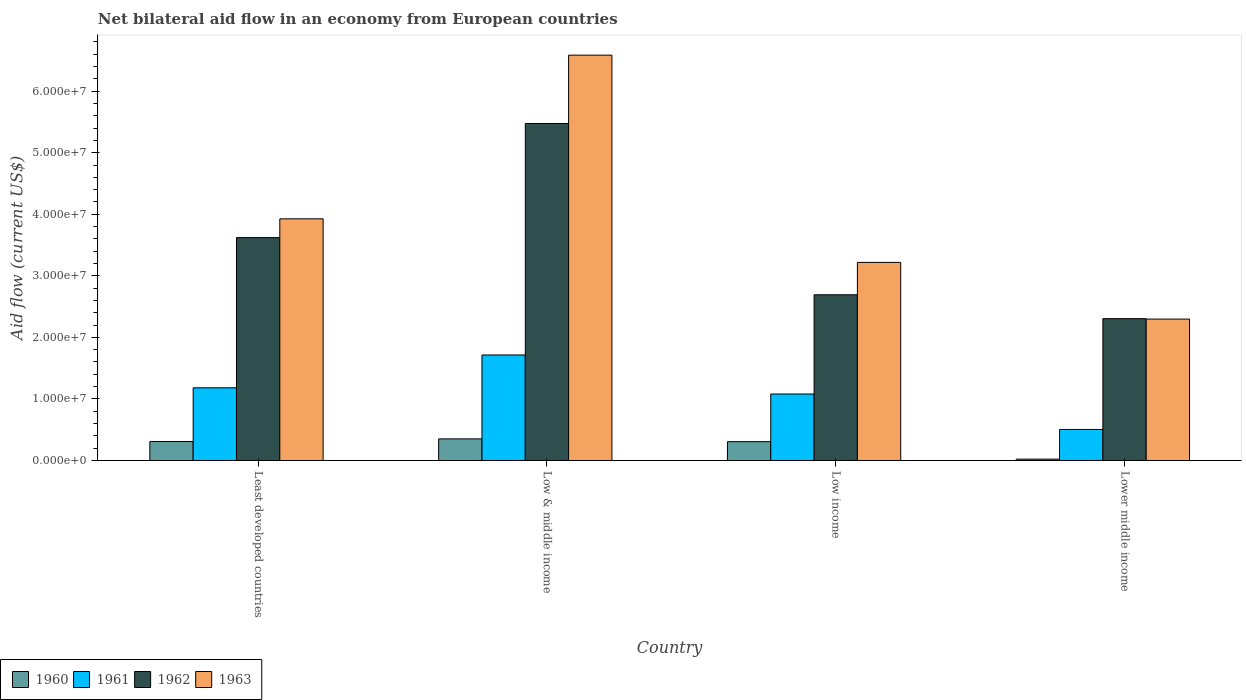How many different coloured bars are there?
Your answer should be compact. 4. Are the number of bars per tick equal to the number of legend labels?
Provide a short and direct response. Yes. Are the number of bars on each tick of the X-axis equal?
Keep it short and to the point. Yes. How many bars are there on the 2nd tick from the right?
Your answer should be compact. 4. What is the label of the 1st group of bars from the left?
Provide a succinct answer. Least developed countries. What is the net bilateral aid flow in 1960 in Least developed countries?
Provide a short and direct response. 3.08e+06. Across all countries, what is the maximum net bilateral aid flow in 1962?
Offer a terse response. 5.48e+07. Across all countries, what is the minimum net bilateral aid flow in 1963?
Offer a very short reply. 2.30e+07. In which country was the net bilateral aid flow in 1961 minimum?
Offer a terse response. Lower middle income. What is the total net bilateral aid flow in 1961 in the graph?
Give a very brief answer. 4.48e+07. What is the difference between the net bilateral aid flow in 1960 in Least developed countries and that in Lower middle income?
Provide a short and direct response. 2.86e+06. What is the difference between the net bilateral aid flow in 1960 in Lower middle income and the net bilateral aid flow in 1961 in Low & middle income?
Ensure brevity in your answer.  -1.69e+07. What is the average net bilateral aid flow in 1963 per country?
Give a very brief answer. 4.01e+07. What is the difference between the net bilateral aid flow of/in 1963 and net bilateral aid flow of/in 1962 in Low income?
Give a very brief answer. 5.26e+06. In how many countries, is the net bilateral aid flow in 1963 greater than 24000000 US$?
Provide a succinct answer. 3. What is the ratio of the net bilateral aid flow in 1962 in Low & middle income to that in Low income?
Your answer should be compact. 2.03. Is the net bilateral aid flow in 1963 in Least developed countries less than that in Low & middle income?
Give a very brief answer. Yes. What is the difference between the highest and the lowest net bilateral aid flow in 1963?
Provide a short and direct response. 4.29e+07. In how many countries, is the net bilateral aid flow in 1960 greater than the average net bilateral aid flow in 1960 taken over all countries?
Your answer should be compact. 3. Is the sum of the net bilateral aid flow in 1963 in Least developed countries and Low income greater than the maximum net bilateral aid flow in 1960 across all countries?
Offer a very short reply. Yes. What does the 2nd bar from the right in Least developed countries represents?
Offer a very short reply. 1962. Are all the bars in the graph horizontal?
Offer a terse response. No. How many countries are there in the graph?
Offer a very short reply. 4. Does the graph contain any zero values?
Your answer should be compact. No. Does the graph contain grids?
Keep it short and to the point. No. What is the title of the graph?
Offer a very short reply. Net bilateral aid flow in an economy from European countries. Does "1992" appear as one of the legend labels in the graph?
Offer a very short reply. No. What is the label or title of the Y-axis?
Provide a short and direct response. Aid flow (current US$). What is the Aid flow (current US$) of 1960 in Least developed countries?
Make the answer very short. 3.08e+06. What is the Aid flow (current US$) in 1961 in Least developed countries?
Provide a short and direct response. 1.18e+07. What is the Aid flow (current US$) of 1962 in Least developed countries?
Your answer should be compact. 3.62e+07. What is the Aid flow (current US$) of 1963 in Least developed countries?
Keep it short and to the point. 3.93e+07. What is the Aid flow (current US$) of 1960 in Low & middle income?
Offer a very short reply. 3.51e+06. What is the Aid flow (current US$) in 1961 in Low & middle income?
Your answer should be very brief. 1.71e+07. What is the Aid flow (current US$) of 1962 in Low & middle income?
Your response must be concise. 5.48e+07. What is the Aid flow (current US$) of 1963 in Low & middle income?
Your answer should be very brief. 6.58e+07. What is the Aid flow (current US$) of 1960 in Low income?
Provide a succinct answer. 3.06e+06. What is the Aid flow (current US$) of 1961 in Low income?
Ensure brevity in your answer.  1.08e+07. What is the Aid flow (current US$) in 1962 in Low income?
Your response must be concise. 2.69e+07. What is the Aid flow (current US$) in 1963 in Low income?
Ensure brevity in your answer.  3.22e+07. What is the Aid flow (current US$) in 1961 in Lower middle income?
Your answer should be compact. 5.04e+06. What is the Aid flow (current US$) of 1962 in Lower middle income?
Keep it short and to the point. 2.30e+07. What is the Aid flow (current US$) of 1963 in Lower middle income?
Keep it short and to the point. 2.30e+07. Across all countries, what is the maximum Aid flow (current US$) of 1960?
Provide a short and direct response. 3.51e+06. Across all countries, what is the maximum Aid flow (current US$) in 1961?
Offer a terse response. 1.71e+07. Across all countries, what is the maximum Aid flow (current US$) of 1962?
Offer a very short reply. 5.48e+07. Across all countries, what is the maximum Aid flow (current US$) in 1963?
Your response must be concise. 6.58e+07. Across all countries, what is the minimum Aid flow (current US$) in 1961?
Ensure brevity in your answer.  5.04e+06. Across all countries, what is the minimum Aid flow (current US$) in 1962?
Offer a very short reply. 2.30e+07. Across all countries, what is the minimum Aid flow (current US$) of 1963?
Give a very brief answer. 2.30e+07. What is the total Aid flow (current US$) of 1960 in the graph?
Your response must be concise. 9.87e+06. What is the total Aid flow (current US$) in 1961 in the graph?
Your answer should be very brief. 4.48e+07. What is the total Aid flow (current US$) of 1962 in the graph?
Ensure brevity in your answer.  1.41e+08. What is the total Aid flow (current US$) in 1963 in the graph?
Offer a terse response. 1.60e+08. What is the difference between the Aid flow (current US$) in 1960 in Least developed countries and that in Low & middle income?
Your answer should be compact. -4.30e+05. What is the difference between the Aid flow (current US$) in 1961 in Least developed countries and that in Low & middle income?
Provide a succinct answer. -5.33e+06. What is the difference between the Aid flow (current US$) in 1962 in Least developed countries and that in Low & middle income?
Ensure brevity in your answer.  -1.85e+07. What is the difference between the Aid flow (current US$) of 1963 in Least developed countries and that in Low & middle income?
Keep it short and to the point. -2.66e+07. What is the difference between the Aid flow (current US$) in 1960 in Least developed countries and that in Low income?
Your answer should be compact. 2.00e+04. What is the difference between the Aid flow (current US$) in 1961 in Least developed countries and that in Low income?
Offer a very short reply. 1.01e+06. What is the difference between the Aid flow (current US$) in 1962 in Least developed countries and that in Low income?
Provide a succinct answer. 9.29e+06. What is the difference between the Aid flow (current US$) in 1963 in Least developed countries and that in Low income?
Keep it short and to the point. 7.08e+06. What is the difference between the Aid flow (current US$) in 1960 in Least developed countries and that in Lower middle income?
Your answer should be very brief. 2.86e+06. What is the difference between the Aid flow (current US$) of 1961 in Least developed countries and that in Lower middle income?
Provide a succinct answer. 6.77e+06. What is the difference between the Aid flow (current US$) in 1962 in Least developed countries and that in Lower middle income?
Make the answer very short. 1.32e+07. What is the difference between the Aid flow (current US$) of 1963 in Least developed countries and that in Lower middle income?
Give a very brief answer. 1.63e+07. What is the difference between the Aid flow (current US$) in 1961 in Low & middle income and that in Low income?
Offer a terse response. 6.34e+06. What is the difference between the Aid flow (current US$) of 1962 in Low & middle income and that in Low income?
Offer a terse response. 2.78e+07. What is the difference between the Aid flow (current US$) in 1963 in Low & middle income and that in Low income?
Your response must be concise. 3.37e+07. What is the difference between the Aid flow (current US$) of 1960 in Low & middle income and that in Lower middle income?
Give a very brief answer. 3.29e+06. What is the difference between the Aid flow (current US$) in 1961 in Low & middle income and that in Lower middle income?
Keep it short and to the point. 1.21e+07. What is the difference between the Aid flow (current US$) of 1962 in Low & middle income and that in Lower middle income?
Your answer should be very brief. 3.17e+07. What is the difference between the Aid flow (current US$) in 1963 in Low & middle income and that in Lower middle income?
Offer a very short reply. 4.29e+07. What is the difference between the Aid flow (current US$) in 1960 in Low income and that in Lower middle income?
Make the answer very short. 2.84e+06. What is the difference between the Aid flow (current US$) of 1961 in Low income and that in Lower middle income?
Offer a terse response. 5.76e+06. What is the difference between the Aid flow (current US$) in 1962 in Low income and that in Lower middle income?
Provide a short and direct response. 3.88e+06. What is the difference between the Aid flow (current US$) of 1963 in Low income and that in Lower middle income?
Keep it short and to the point. 9.21e+06. What is the difference between the Aid flow (current US$) of 1960 in Least developed countries and the Aid flow (current US$) of 1961 in Low & middle income?
Your answer should be very brief. -1.41e+07. What is the difference between the Aid flow (current US$) of 1960 in Least developed countries and the Aid flow (current US$) of 1962 in Low & middle income?
Give a very brief answer. -5.17e+07. What is the difference between the Aid flow (current US$) in 1960 in Least developed countries and the Aid flow (current US$) in 1963 in Low & middle income?
Give a very brief answer. -6.28e+07. What is the difference between the Aid flow (current US$) of 1961 in Least developed countries and the Aid flow (current US$) of 1962 in Low & middle income?
Your answer should be compact. -4.29e+07. What is the difference between the Aid flow (current US$) of 1961 in Least developed countries and the Aid flow (current US$) of 1963 in Low & middle income?
Your answer should be very brief. -5.40e+07. What is the difference between the Aid flow (current US$) of 1962 in Least developed countries and the Aid flow (current US$) of 1963 in Low & middle income?
Provide a succinct answer. -2.96e+07. What is the difference between the Aid flow (current US$) in 1960 in Least developed countries and the Aid flow (current US$) in 1961 in Low income?
Provide a succinct answer. -7.72e+06. What is the difference between the Aid flow (current US$) of 1960 in Least developed countries and the Aid flow (current US$) of 1962 in Low income?
Give a very brief answer. -2.38e+07. What is the difference between the Aid flow (current US$) in 1960 in Least developed countries and the Aid flow (current US$) in 1963 in Low income?
Offer a very short reply. -2.91e+07. What is the difference between the Aid flow (current US$) of 1961 in Least developed countries and the Aid flow (current US$) of 1962 in Low income?
Offer a terse response. -1.51e+07. What is the difference between the Aid flow (current US$) in 1961 in Least developed countries and the Aid flow (current US$) in 1963 in Low income?
Offer a terse response. -2.04e+07. What is the difference between the Aid flow (current US$) in 1962 in Least developed countries and the Aid flow (current US$) in 1963 in Low income?
Provide a short and direct response. 4.03e+06. What is the difference between the Aid flow (current US$) in 1960 in Least developed countries and the Aid flow (current US$) in 1961 in Lower middle income?
Offer a terse response. -1.96e+06. What is the difference between the Aid flow (current US$) in 1960 in Least developed countries and the Aid flow (current US$) in 1962 in Lower middle income?
Your answer should be compact. -2.00e+07. What is the difference between the Aid flow (current US$) in 1960 in Least developed countries and the Aid flow (current US$) in 1963 in Lower middle income?
Provide a short and direct response. -1.99e+07. What is the difference between the Aid flow (current US$) of 1961 in Least developed countries and the Aid flow (current US$) of 1962 in Lower middle income?
Give a very brief answer. -1.12e+07. What is the difference between the Aid flow (current US$) in 1961 in Least developed countries and the Aid flow (current US$) in 1963 in Lower middle income?
Your answer should be very brief. -1.12e+07. What is the difference between the Aid flow (current US$) in 1962 in Least developed countries and the Aid flow (current US$) in 1963 in Lower middle income?
Ensure brevity in your answer.  1.32e+07. What is the difference between the Aid flow (current US$) in 1960 in Low & middle income and the Aid flow (current US$) in 1961 in Low income?
Your answer should be very brief. -7.29e+06. What is the difference between the Aid flow (current US$) of 1960 in Low & middle income and the Aid flow (current US$) of 1962 in Low income?
Your answer should be compact. -2.34e+07. What is the difference between the Aid flow (current US$) of 1960 in Low & middle income and the Aid flow (current US$) of 1963 in Low income?
Make the answer very short. -2.87e+07. What is the difference between the Aid flow (current US$) in 1961 in Low & middle income and the Aid flow (current US$) in 1962 in Low income?
Your response must be concise. -9.78e+06. What is the difference between the Aid flow (current US$) of 1961 in Low & middle income and the Aid flow (current US$) of 1963 in Low income?
Make the answer very short. -1.50e+07. What is the difference between the Aid flow (current US$) in 1962 in Low & middle income and the Aid flow (current US$) in 1963 in Low income?
Provide a short and direct response. 2.26e+07. What is the difference between the Aid flow (current US$) of 1960 in Low & middle income and the Aid flow (current US$) of 1961 in Lower middle income?
Offer a very short reply. -1.53e+06. What is the difference between the Aid flow (current US$) of 1960 in Low & middle income and the Aid flow (current US$) of 1962 in Lower middle income?
Provide a short and direct response. -1.95e+07. What is the difference between the Aid flow (current US$) of 1960 in Low & middle income and the Aid flow (current US$) of 1963 in Lower middle income?
Provide a succinct answer. -1.95e+07. What is the difference between the Aid flow (current US$) in 1961 in Low & middle income and the Aid flow (current US$) in 1962 in Lower middle income?
Provide a short and direct response. -5.90e+06. What is the difference between the Aid flow (current US$) of 1961 in Low & middle income and the Aid flow (current US$) of 1963 in Lower middle income?
Provide a succinct answer. -5.83e+06. What is the difference between the Aid flow (current US$) in 1962 in Low & middle income and the Aid flow (current US$) in 1963 in Lower middle income?
Your answer should be compact. 3.18e+07. What is the difference between the Aid flow (current US$) in 1960 in Low income and the Aid flow (current US$) in 1961 in Lower middle income?
Provide a short and direct response. -1.98e+06. What is the difference between the Aid flow (current US$) of 1960 in Low income and the Aid flow (current US$) of 1962 in Lower middle income?
Make the answer very short. -2.00e+07. What is the difference between the Aid flow (current US$) of 1960 in Low income and the Aid flow (current US$) of 1963 in Lower middle income?
Your response must be concise. -1.99e+07. What is the difference between the Aid flow (current US$) of 1961 in Low income and the Aid flow (current US$) of 1962 in Lower middle income?
Provide a short and direct response. -1.22e+07. What is the difference between the Aid flow (current US$) in 1961 in Low income and the Aid flow (current US$) in 1963 in Lower middle income?
Your answer should be compact. -1.22e+07. What is the difference between the Aid flow (current US$) of 1962 in Low income and the Aid flow (current US$) of 1963 in Lower middle income?
Keep it short and to the point. 3.95e+06. What is the average Aid flow (current US$) in 1960 per country?
Make the answer very short. 2.47e+06. What is the average Aid flow (current US$) of 1961 per country?
Give a very brief answer. 1.12e+07. What is the average Aid flow (current US$) in 1962 per country?
Offer a terse response. 3.52e+07. What is the average Aid flow (current US$) of 1963 per country?
Ensure brevity in your answer.  4.01e+07. What is the difference between the Aid flow (current US$) in 1960 and Aid flow (current US$) in 1961 in Least developed countries?
Keep it short and to the point. -8.73e+06. What is the difference between the Aid flow (current US$) of 1960 and Aid flow (current US$) of 1962 in Least developed countries?
Offer a terse response. -3.31e+07. What is the difference between the Aid flow (current US$) of 1960 and Aid flow (current US$) of 1963 in Least developed countries?
Your response must be concise. -3.62e+07. What is the difference between the Aid flow (current US$) in 1961 and Aid flow (current US$) in 1962 in Least developed countries?
Your response must be concise. -2.44e+07. What is the difference between the Aid flow (current US$) in 1961 and Aid flow (current US$) in 1963 in Least developed countries?
Provide a succinct answer. -2.74e+07. What is the difference between the Aid flow (current US$) in 1962 and Aid flow (current US$) in 1963 in Least developed countries?
Provide a succinct answer. -3.05e+06. What is the difference between the Aid flow (current US$) in 1960 and Aid flow (current US$) in 1961 in Low & middle income?
Offer a terse response. -1.36e+07. What is the difference between the Aid flow (current US$) of 1960 and Aid flow (current US$) of 1962 in Low & middle income?
Keep it short and to the point. -5.12e+07. What is the difference between the Aid flow (current US$) of 1960 and Aid flow (current US$) of 1963 in Low & middle income?
Offer a terse response. -6.23e+07. What is the difference between the Aid flow (current US$) of 1961 and Aid flow (current US$) of 1962 in Low & middle income?
Give a very brief answer. -3.76e+07. What is the difference between the Aid flow (current US$) in 1961 and Aid flow (current US$) in 1963 in Low & middle income?
Provide a succinct answer. -4.87e+07. What is the difference between the Aid flow (current US$) in 1962 and Aid flow (current US$) in 1963 in Low & middle income?
Offer a terse response. -1.11e+07. What is the difference between the Aid flow (current US$) in 1960 and Aid flow (current US$) in 1961 in Low income?
Provide a succinct answer. -7.74e+06. What is the difference between the Aid flow (current US$) in 1960 and Aid flow (current US$) in 1962 in Low income?
Your answer should be compact. -2.39e+07. What is the difference between the Aid flow (current US$) of 1960 and Aid flow (current US$) of 1963 in Low income?
Keep it short and to the point. -2.91e+07. What is the difference between the Aid flow (current US$) of 1961 and Aid flow (current US$) of 1962 in Low income?
Give a very brief answer. -1.61e+07. What is the difference between the Aid flow (current US$) of 1961 and Aid flow (current US$) of 1963 in Low income?
Offer a terse response. -2.14e+07. What is the difference between the Aid flow (current US$) of 1962 and Aid flow (current US$) of 1963 in Low income?
Your response must be concise. -5.26e+06. What is the difference between the Aid flow (current US$) of 1960 and Aid flow (current US$) of 1961 in Lower middle income?
Your answer should be compact. -4.82e+06. What is the difference between the Aid flow (current US$) of 1960 and Aid flow (current US$) of 1962 in Lower middle income?
Give a very brief answer. -2.28e+07. What is the difference between the Aid flow (current US$) of 1960 and Aid flow (current US$) of 1963 in Lower middle income?
Offer a very short reply. -2.28e+07. What is the difference between the Aid flow (current US$) in 1961 and Aid flow (current US$) in 1962 in Lower middle income?
Offer a very short reply. -1.80e+07. What is the difference between the Aid flow (current US$) in 1961 and Aid flow (current US$) in 1963 in Lower middle income?
Keep it short and to the point. -1.79e+07. What is the difference between the Aid flow (current US$) in 1962 and Aid flow (current US$) in 1963 in Lower middle income?
Provide a succinct answer. 7.00e+04. What is the ratio of the Aid flow (current US$) of 1960 in Least developed countries to that in Low & middle income?
Provide a succinct answer. 0.88. What is the ratio of the Aid flow (current US$) of 1961 in Least developed countries to that in Low & middle income?
Your answer should be compact. 0.69. What is the ratio of the Aid flow (current US$) in 1962 in Least developed countries to that in Low & middle income?
Offer a very short reply. 0.66. What is the ratio of the Aid flow (current US$) in 1963 in Least developed countries to that in Low & middle income?
Your answer should be very brief. 0.6. What is the ratio of the Aid flow (current US$) in 1960 in Least developed countries to that in Low income?
Make the answer very short. 1.01. What is the ratio of the Aid flow (current US$) of 1961 in Least developed countries to that in Low income?
Keep it short and to the point. 1.09. What is the ratio of the Aid flow (current US$) in 1962 in Least developed countries to that in Low income?
Keep it short and to the point. 1.35. What is the ratio of the Aid flow (current US$) in 1963 in Least developed countries to that in Low income?
Provide a succinct answer. 1.22. What is the ratio of the Aid flow (current US$) in 1960 in Least developed countries to that in Lower middle income?
Your response must be concise. 14. What is the ratio of the Aid flow (current US$) in 1961 in Least developed countries to that in Lower middle income?
Provide a short and direct response. 2.34. What is the ratio of the Aid flow (current US$) in 1962 in Least developed countries to that in Lower middle income?
Keep it short and to the point. 1.57. What is the ratio of the Aid flow (current US$) of 1963 in Least developed countries to that in Lower middle income?
Provide a short and direct response. 1.71. What is the ratio of the Aid flow (current US$) of 1960 in Low & middle income to that in Low income?
Your answer should be very brief. 1.15. What is the ratio of the Aid flow (current US$) in 1961 in Low & middle income to that in Low income?
Provide a short and direct response. 1.59. What is the ratio of the Aid flow (current US$) in 1962 in Low & middle income to that in Low income?
Offer a terse response. 2.03. What is the ratio of the Aid flow (current US$) in 1963 in Low & middle income to that in Low income?
Your response must be concise. 2.05. What is the ratio of the Aid flow (current US$) of 1960 in Low & middle income to that in Lower middle income?
Give a very brief answer. 15.95. What is the ratio of the Aid flow (current US$) of 1961 in Low & middle income to that in Lower middle income?
Make the answer very short. 3.4. What is the ratio of the Aid flow (current US$) in 1962 in Low & middle income to that in Lower middle income?
Provide a succinct answer. 2.38. What is the ratio of the Aid flow (current US$) in 1963 in Low & middle income to that in Lower middle income?
Give a very brief answer. 2.87. What is the ratio of the Aid flow (current US$) of 1960 in Low income to that in Lower middle income?
Offer a very short reply. 13.91. What is the ratio of the Aid flow (current US$) of 1961 in Low income to that in Lower middle income?
Offer a very short reply. 2.14. What is the ratio of the Aid flow (current US$) in 1962 in Low income to that in Lower middle income?
Give a very brief answer. 1.17. What is the ratio of the Aid flow (current US$) in 1963 in Low income to that in Lower middle income?
Provide a succinct answer. 1.4. What is the difference between the highest and the second highest Aid flow (current US$) of 1961?
Provide a short and direct response. 5.33e+06. What is the difference between the highest and the second highest Aid flow (current US$) of 1962?
Make the answer very short. 1.85e+07. What is the difference between the highest and the second highest Aid flow (current US$) of 1963?
Offer a terse response. 2.66e+07. What is the difference between the highest and the lowest Aid flow (current US$) of 1960?
Your response must be concise. 3.29e+06. What is the difference between the highest and the lowest Aid flow (current US$) of 1961?
Provide a succinct answer. 1.21e+07. What is the difference between the highest and the lowest Aid flow (current US$) of 1962?
Your answer should be very brief. 3.17e+07. What is the difference between the highest and the lowest Aid flow (current US$) of 1963?
Your response must be concise. 4.29e+07. 